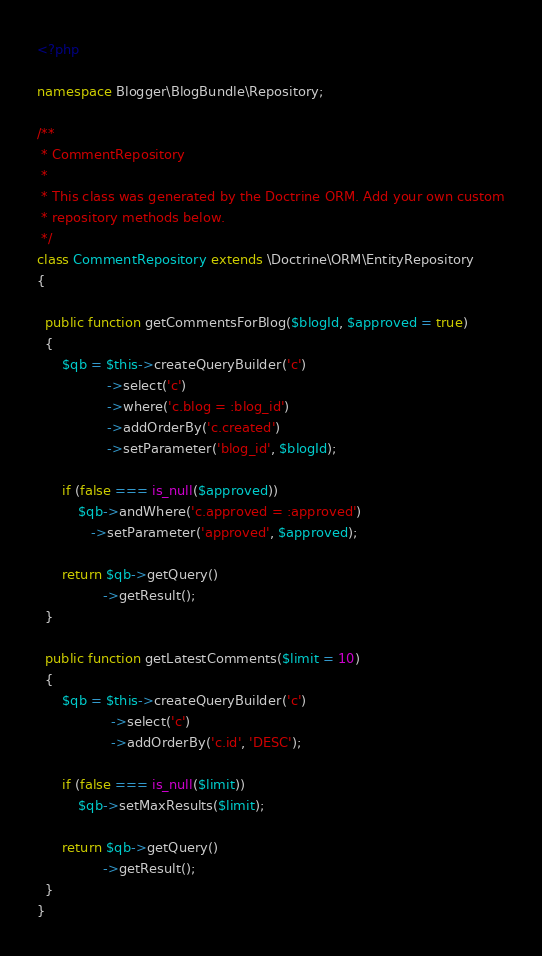<code> <loc_0><loc_0><loc_500><loc_500><_PHP_><?php

namespace Blogger\BlogBundle\Repository;

/**
 * CommentRepository
 *
 * This class was generated by the Doctrine ORM. Add your own custom
 * repository methods below.
 */
class CommentRepository extends \Doctrine\ORM\EntityRepository
{

  public function getCommentsForBlog($blogId, $approved = true)
  {
      $qb = $this->createQueryBuilder('c')
                 ->select('c')
                 ->where('c.blog = :blog_id')
                 ->addOrderBy('c.created')
                 ->setParameter('blog_id', $blogId);

      if (false === is_null($approved))
          $qb->andWhere('c.approved = :approved')
             ->setParameter('approved', $approved);

      return $qb->getQuery()
                ->getResult();
  }

  public function getLatestComments($limit = 10)
  {
      $qb = $this->createQueryBuilder('c')
                  ->select('c')
                  ->addOrderBy('c.id', 'DESC');

      if (false === is_null($limit))
          $qb->setMaxResults($limit);

      return $qb->getQuery()
                ->getResult();
  }
}
</code> 